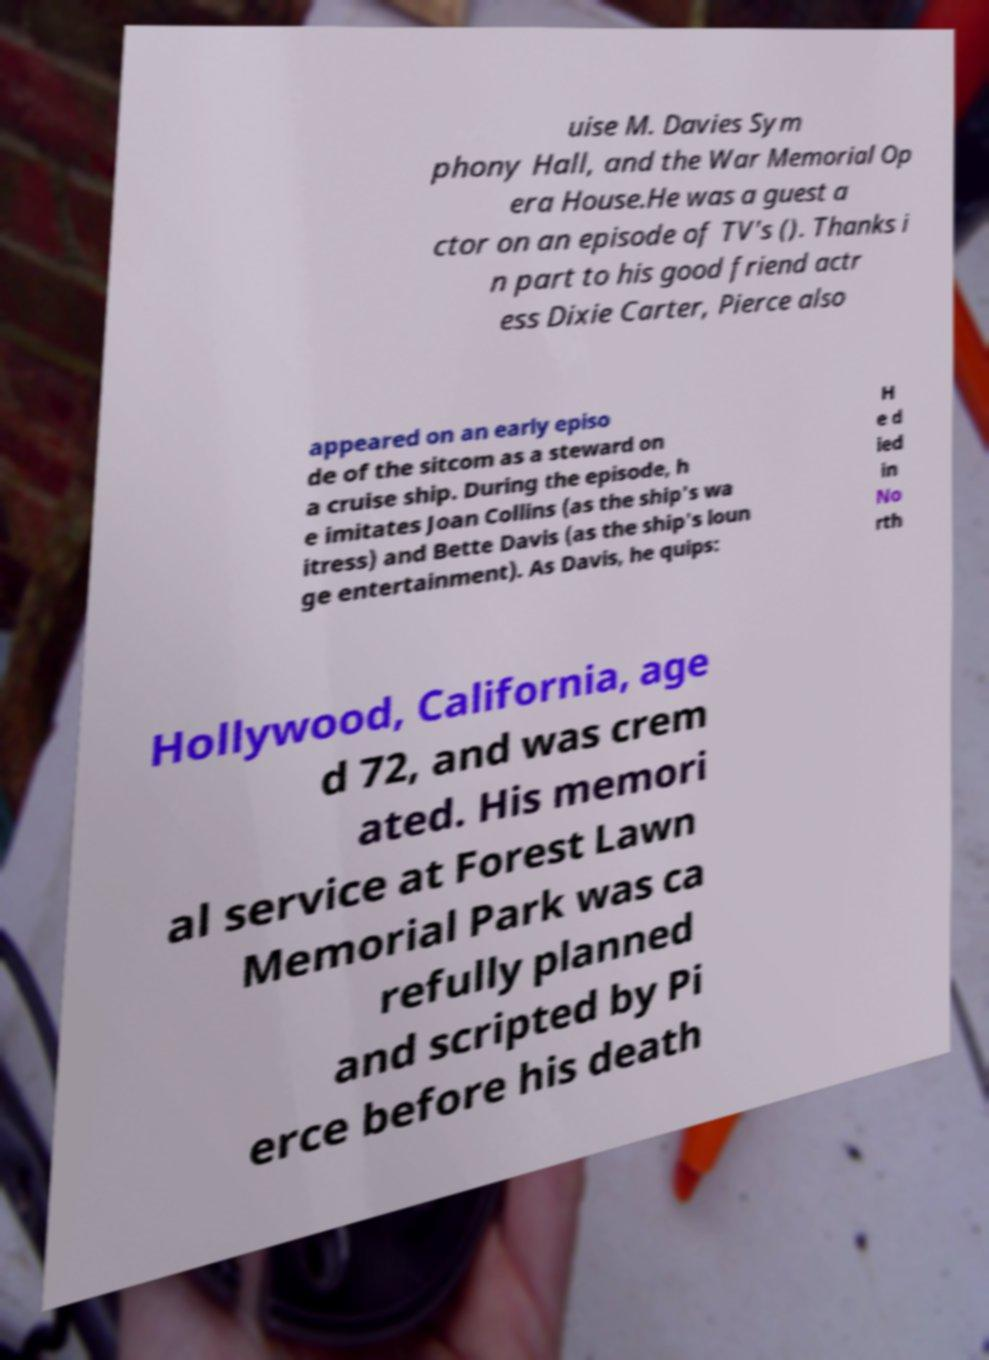Please read and relay the text visible in this image. What does it say? uise M. Davies Sym phony Hall, and the War Memorial Op era House.He was a guest a ctor on an episode of TV's (). Thanks i n part to his good friend actr ess Dixie Carter, Pierce also appeared on an early episo de of the sitcom as a steward on a cruise ship. During the episode, h e imitates Joan Collins (as the ship's wa itress) and Bette Davis (as the ship's loun ge entertainment). As Davis, he quips: H e d ied in No rth Hollywood, California, age d 72, and was crem ated. His memori al service at Forest Lawn Memorial Park was ca refully planned and scripted by Pi erce before his death 